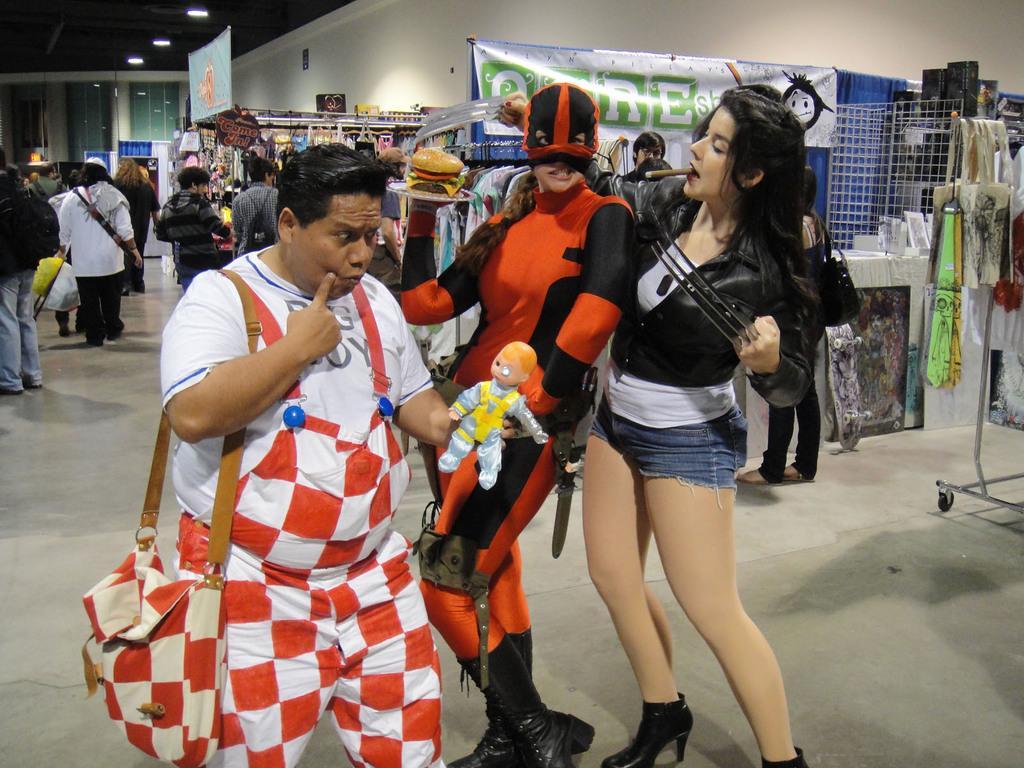Please provide a concise description of this image. In this image we can see a group of people standing on the floor. One person wearing a dress is holding a doll in his hand and carrying a bag. One woman wearing orange dress is holding a plate containing food in it. In the background, we can see group of clothes places on the rack. A skateboard on the ground and a banner with some text on it and some lights. 